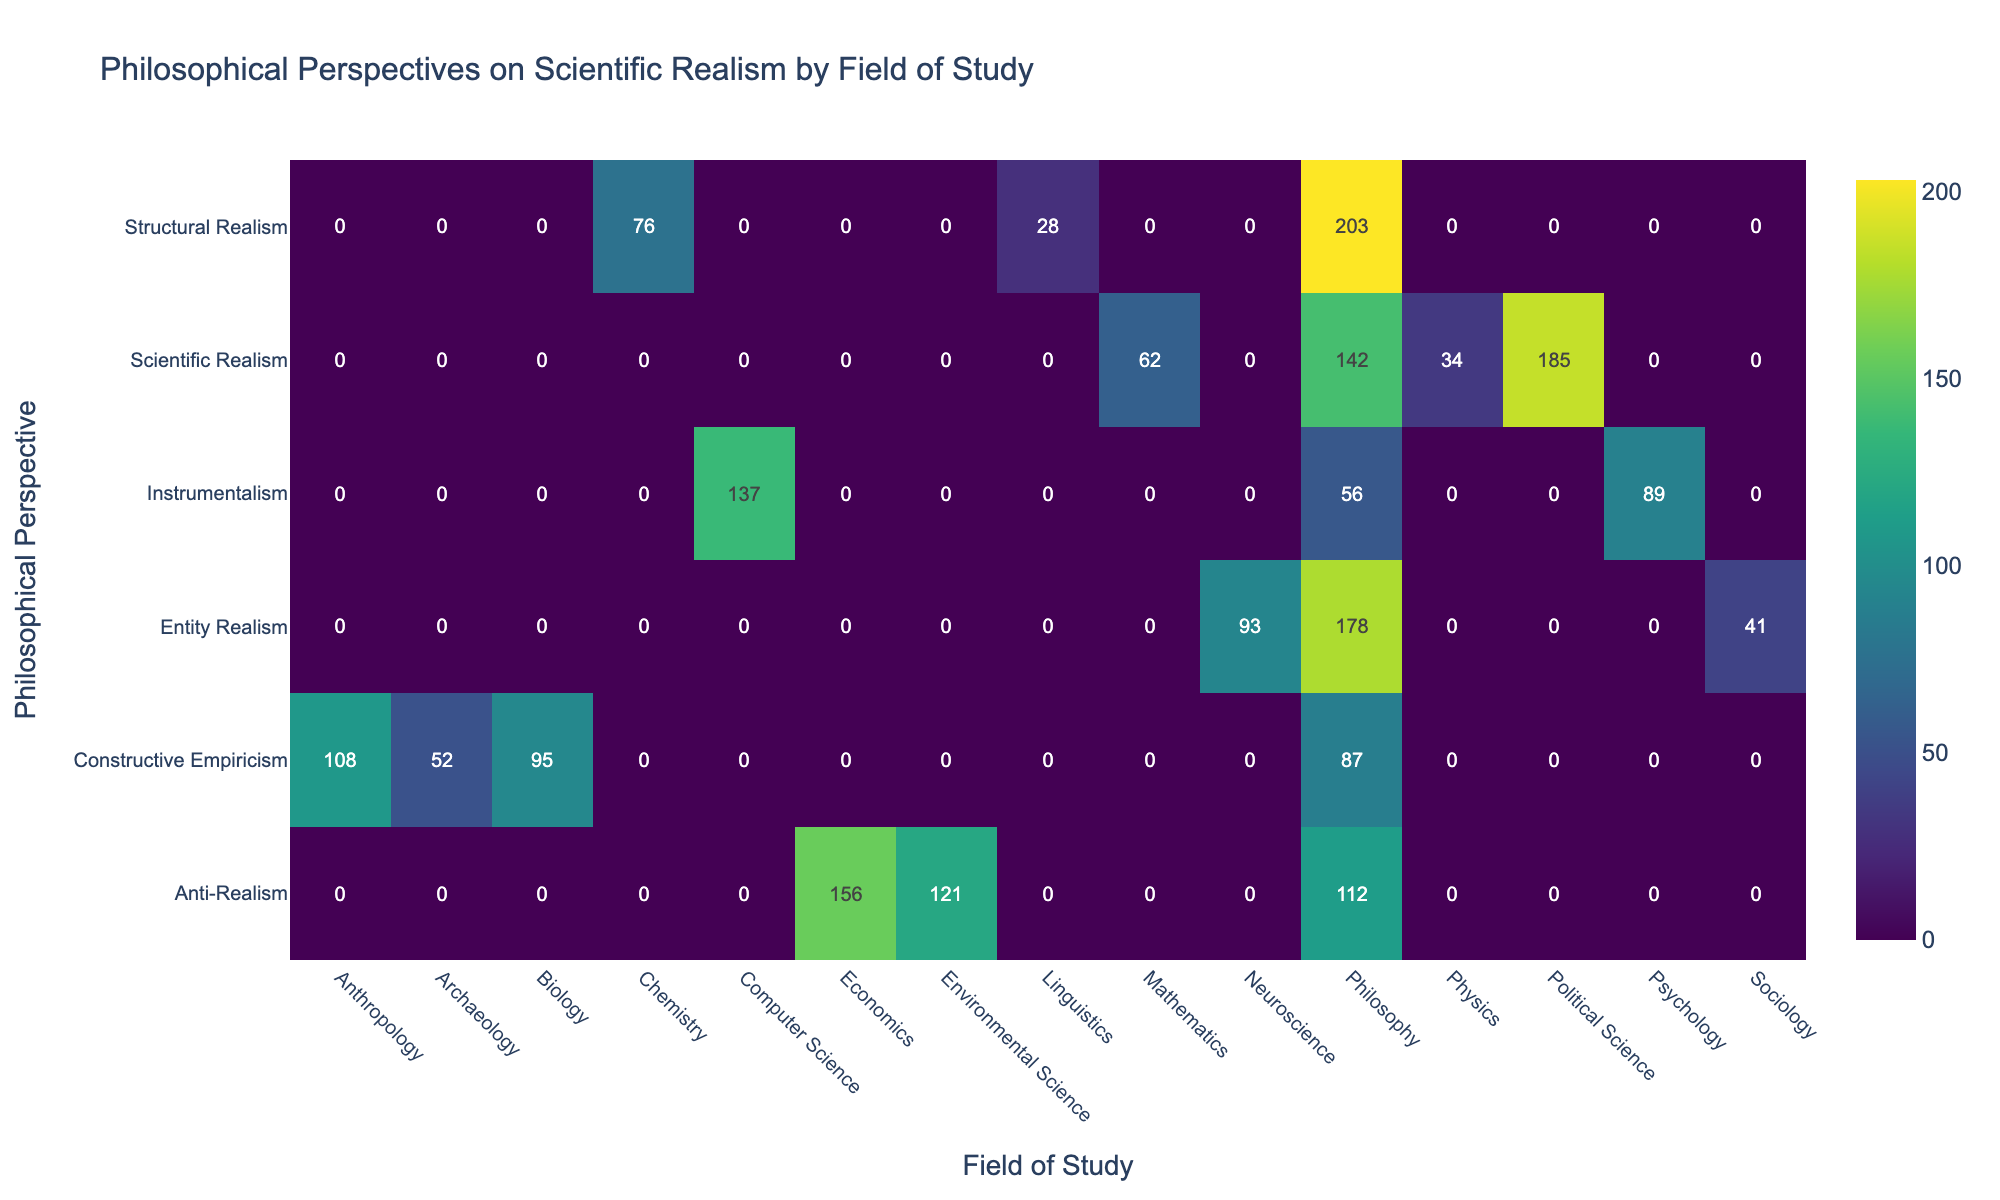What is the highest number of citations for the Constructive Empiricism perspective? The highest citation for Constructive Empiricism is found in the British Journal for the Philosophy of Science in 2017 with 95 citations.
Answer: 95 Which philosophical perspective has the least number of citations in Psychology? The Instrumentalism perspective published in Synthese in 2018 has the least number of citations in Psychology, with 89 citations.
Answer: 89 What is the total number of citations for Entity Realism across all fields? To find the total citations for Entity Realism, we sum the values: 178 (Philosophy of Science, 2016) + 41 (European Journal for Philosophy of Science, 2020) + 93 (Synthese, 2019) = 312.
Answer: 312 Is there a publication for Structural Realism in the field of Mathematics? Checking the table, there are no entries for Structural Realism in the Mathematics field, thus the answer is no.
Answer: No What is the average number of citations for the Anti-Realism perspective across all publications? To calculate the average, first sum the citations: 112 (Synthese, 2018) + 156 (British Journal for the Philosophy of Science, 2016) + 121 (Philosophy of Science, 2018) = 389, and since there are 3 entries, the average is 389 / 3 = 129.67.
Answer: 129.67 Which field of study has the highest total citations, and what is that total for Scientific Realism? By analyzing the table, the highest total citations for Scientific Realism come from the Philosophy of Science in 2016 with 185 citations. There are no higher values in other fields.
Answer: 185 How many perspectives have been published in the field of Sociology? In the table, there is only one entry for Entity Realism in Sociology, published in 2020 with 41 citations.
Answer: 1 Which two perspectives have the highest combined citations in the Philosophy of Science? For the Philosophy of Science, Scientific Realism has 142 (2018) + 178 (2016) and Anti-Realism has 121 (2018). Thus, combined: 142 + 178 + 121 = 441 is the total citations for these two perspectives.
Answer: 441 